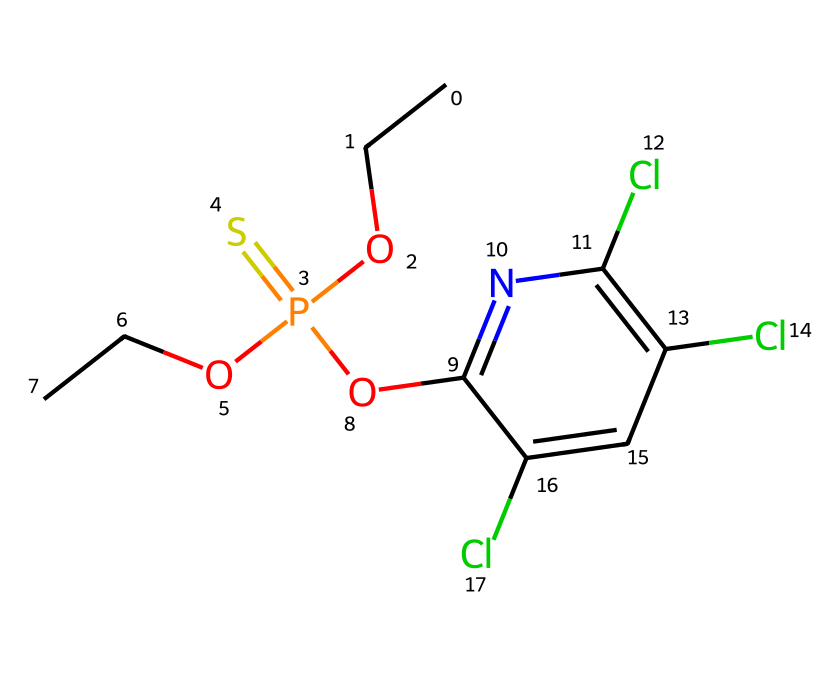What is the molecular formula of chlorpyrifos? The SMILES notation indicates the presence of carbon (C), hydrogen (H), oxygen (O), phosphorus (P), sulfur (S), nitrogen (N), and chlorine (Cl) atoms. By counting each type from the SMILES representation, we deduce the molecular formula as C9H11Cl3N1O3PS1.
Answer: C9H11Cl3N1O3PS1 How many chlorine atoms are present in chlorpyrifos? The SMILES notation shows 'Cl' three times, indicating that there are three chlorine atoms in the structure of chlorpyrifos.
Answer: 3 What functional groups are present in chlorpyrifos? Upon analyzing the SMILES structure, we find that it contains a phosphonate group (P(=S)(O)(O)) and several aromatic rings (indicated by 'c'). These features are characteristic of chlorpyrifos.
Answer: phosphonate, aromatic Is chlorpyrifos a phosphorothioate or a phosphonate? Examining the SMILES code reveals a phosphorus atom bonded to a sulfur (P(=S)), which is characteristic of phosphorothioate compounds. This indicates that chlorpyrifos is classified as a phosphorothioate.
Answer: phosphorothioate What role do chlorine atoms play in chlorpyrifos's functionality? The presence of chlorine atoms in chlorpyrifos often enhances its effectiveness as a pesticide, increasing its lipophilicity which aids in penetration through biological membranes. This contributes to its efficacy as an insecticide.
Answer: enhance efficacy What type of pesticide is chlorpyrifos mainly classified as? Chlorpyrifos is primarily classified as an organophosphate pesticide due to its chemical structure and mechanism of action, which involves inhibiting acetylcholinesterase, an important enzyme in the nervous system of pests.
Answer: organophosphate 